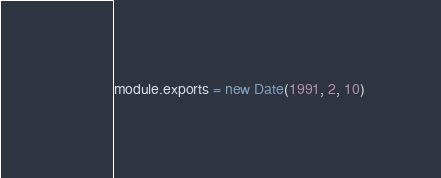Convert code to text. <code><loc_0><loc_0><loc_500><loc_500><_JavaScript_>module.exports = new Date(1991, 2, 10)
</code> 